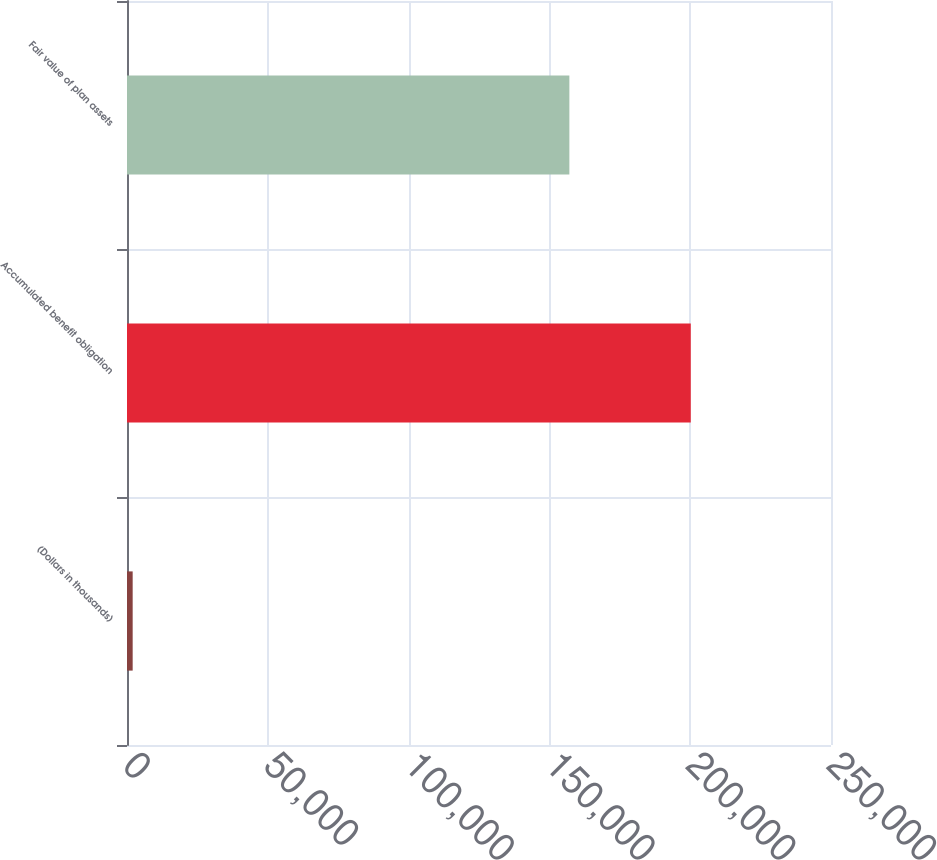<chart> <loc_0><loc_0><loc_500><loc_500><bar_chart><fcel>(Dollars in thousands)<fcel>Accumulated benefit obligation<fcel>Fair value of plan assets<nl><fcel>2014<fcel>200205<fcel>157090<nl></chart> 